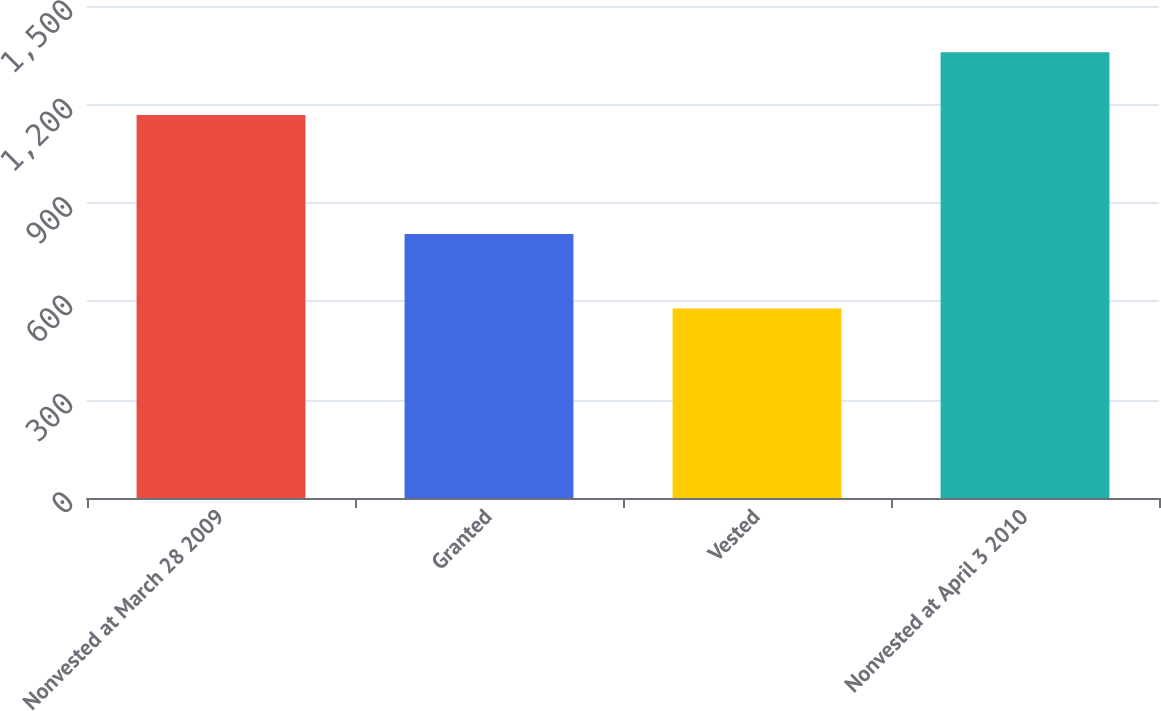<chart> <loc_0><loc_0><loc_500><loc_500><bar_chart><fcel>Nonvested at March 28 2009<fcel>Granted<fcel>Vested<fcel>Nonvested at April 3 2010<nl><fcel>1168<fcel>805<fcel>578<fcel>1359<nl></chart> 